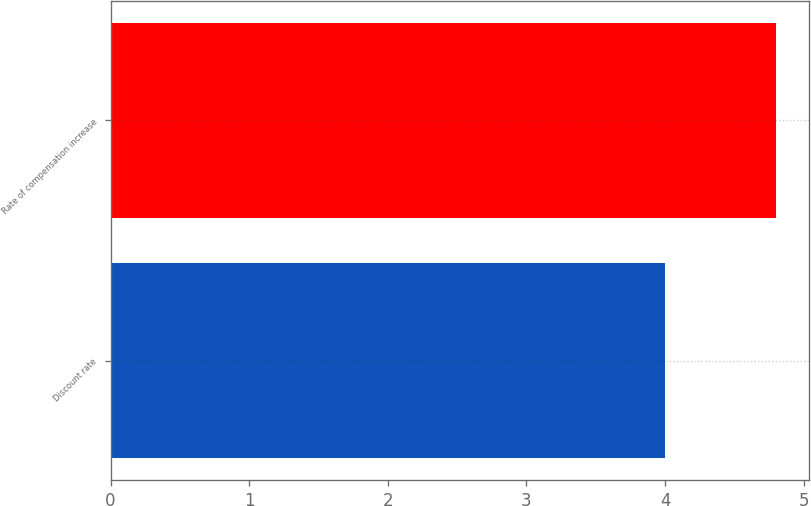<chart> <loc_0><loc_0><loc_500><loc_500><bar_chart><fcel>Discount rate<fcel>Rate of compensation increase<nl><fcel>4<fcel>4.8<nl></chart> 